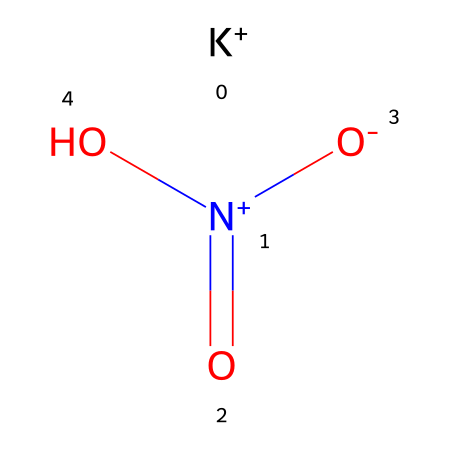What is the name of the chemical represented by this structure? The structure indicates potassium as part of its composition (the K at the beginning of the SMILES) and a nitrate group (N+ with three O atoms). Therefore, the name of this compound is potassium nitrate.
Answer: potassium nitrate How many oxygen atoms are present in the structure? Analyzing the SMILES, there are three oxygen atoms connected: two are in the nitrate group, and one is part of a hydroxyl (OH) group. Count them explicitly indicates three oxygens.
Answer: three What is the oxidation state of nitrogen in this compound? The nitrogen in the structure shows a formal positive charge (N+) and is bonded to three oxygens, typically indicating an oxidation state of +5. This is derived from the usual -2 for normal oxygen in this context, balancing the overall charge.
Answer: +5 What type of molecule is potassium nitrate classified as? The structure has a metal cation (K+) and an anionic group (nitrate). This means it is classified as an inorganic salt due to the presence of these charged species.
Answer: inorganic salt Which property of potassium nitrate allows it to be used in meat curing? Potassium nitrate is known for its ability to inhibit spoilage and bacterial growth, which is valuable in preserving meats. This is mainly because of the nitrate ions, which can help in preventing botulism during the curing process.
Answer: preservation How many bonds are there between the nitrogen and the oxygen in potassium nitrate? In the nitrate group, the nitrogen forms one double bond with one oxygen and single bonds with the other two oxygens. That means there is a total of one double bond and two single bonds. Counting these gives three bonds in total.
Answer: three 